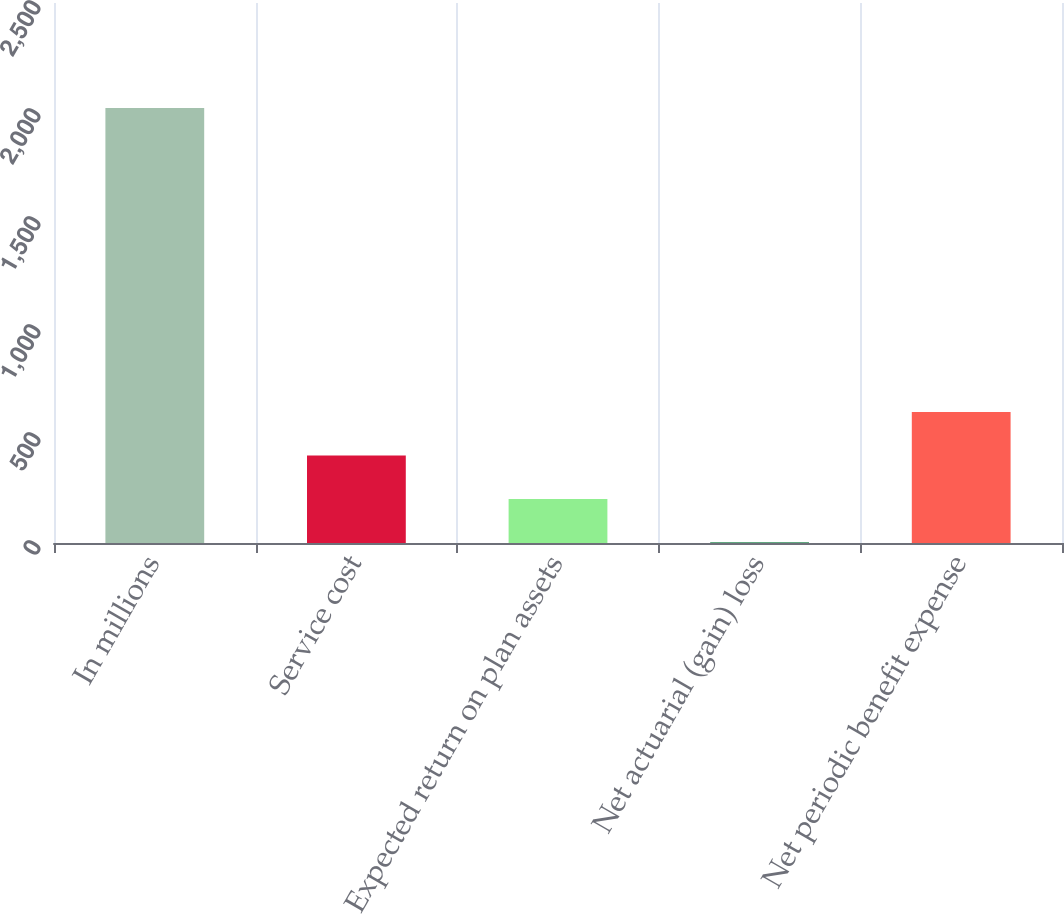<chart> <loc_0><loc_0><loc_500><loc_500><bar_chart><fcel>In millions<fcel>Service cost<fcel>Expected return on plan assets<fcel>Net actuarial (gain) loss<fcel>Net periodic benefit expense<nl><fcel>2014<fcel>405.28<fcel>204.19<fcel>3.1<fcel>606.37<nl></chart> 